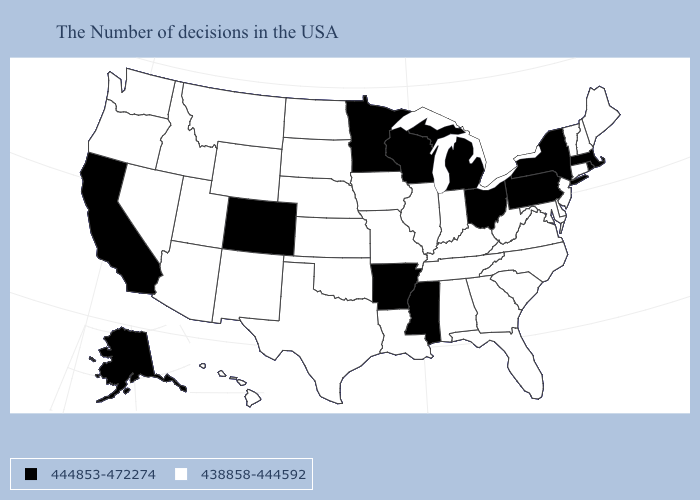Does Mississippi have the same value as Rhode Island?
Give a very brief answer. Yes. Among the states that border Michigan , which have the highest value?
Answer briefly. Ohio, Wisconsin. Is the legend a continuous bar?
Concise answer only. No. Does Nebraska have a lower value than Minnesota?
Concise answer only. Yes. What is the value of Mississippi?
Keep it brief. 444853-472274. Does New Jersey have a lower value than Kansas?
Give a very brief answer. No. Does Kentucky have a higher value than California?
Give a very brief answer. No. Which states hav the highest value in the South?
Keep it brief. Mississippi, Arkansas. What is the highest value in the West ?
Keep it brief. 444853-472274. Name the states that have a value in the range 444853-472274?
Concise answer only. Massachusetts, Rhode Island, New York, Pennsylvania, Ohio, Michigan, Wisconsin, Mississippi, Arkansas, Minnesota, Colorado, California, Alaska. Name the states that have a value in the range 438858-444592?
Write a very short answer. Maine, New Hampshire, Vermont, Connecticut, New Jersey, Delaware, Maryland, Virginia, North Carolina, South Carolina, West Virginia, Florida, Georgia, Kentucky, Indiana, Alabama, Tennessee, Illinois, Louisiana, Missouri, Iowa, Kansas, Nebraska, Oklahoma, Texas, South Dakota, North Dakota, Wyoming, New Mexico, Utah, Montana, Arizona, Idaho, Nevada, Washington, Oregon, Hawaii. What is the value of Illinois?
Quick response, please. 438858-444592. Name the states that have a value in the range 438858-444592?
Quick response, please. Maine, New Hampshire, Vermont, Connecticut, New Jersey, Delaware, Maryland, Virginia, North Carolina, South Carolina, West Virginia, Florida, Georgia, Kentucky, Indiana, Alabama, Tennessee, Illinois, Louisiana, Missouri, Iowa, Kansas, Nebraska, Oklahoma, Texas, South Dakota, North Dakota, Wyoming, New Mexico, Utah, Montana, Arizona, Idaho, Nevada, Washington, Oregon, Hawaii. Among the states that border Minnesota , which have the lowest value?
Write a very short answer. Iowa, South Dakota, North Dakota. 